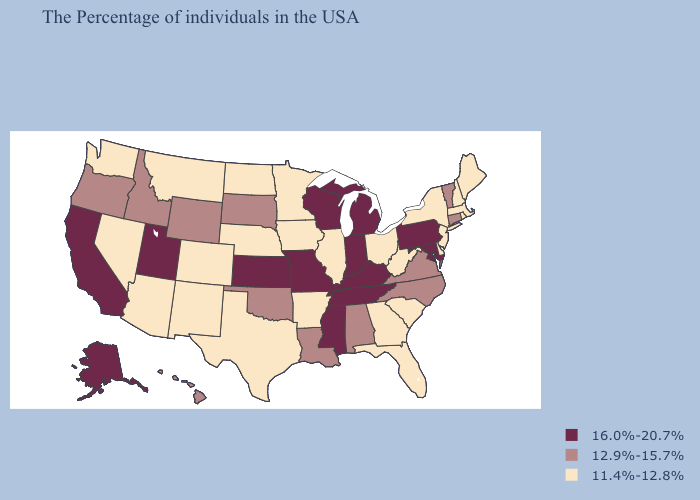Among the states that border New Hampshire , does Vermont have the highest value?
Write a very short answer. Yes. Among the states that border Kansas , which have the lowest value?
Short answer required. Nebraska, Colorado. What is the highest value in the USA?
Be succinct. 16.0%-20.7%. Among the states that border Georgia , does North Carolina have the lowest value?
Write a very short answer. No. Which states have the highest value in the USA?
Concise answer only. Maryland, Pennsylvania, Michigan, Kentucky, Indiana, Tennessee, Wisconsin, Mississippi, Missouri, Kansas, Utah, California, Alaska. What is the value of Florida?
Be succinct. 11.4%-12.8%. Among the states that border Wyoming , which have the lowest value?
Be succinct. Nebraska, Colorado, Montana. What is the highest value in the Northeast ?
Answer briefly. 16.0%-20.7%. Does Michigan have the highest value in the USA?
Quick response, please. Yes. Does Utah have the highest value in the USA?
Keep it brief. Yes. What is the value of West Virginia?
Give a very brief answer. 11.4%-12.8%. Is the legend a continuous bar?
Give a very brief answer. No. Name the states that have a value in the range 12.9%-15.7%?
Write a very short answer. Vermont, Connecticut, Virginia, North Carolina, Alabama, Louisiana, Oklahoma, South Dakota, Wyoming, Idaho, Oregon, Hawaii. What is the value of Montana?
Quick response, please. 11.4%-12.8%. What is the value of Kansas?
Give a very brief answer. 16.0%-20.7%. 